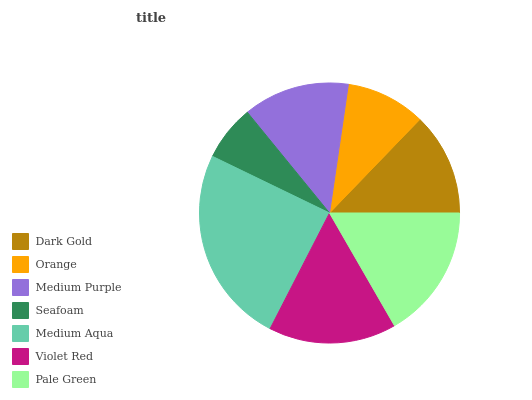Is Seafoam the minimum?
Answer yes or no. Yes. Is Medium Aqua the maximum?
Answer yes or no. Yes. Is Orange the minimum?
Answer yes or no. No. Is Orange the maximum?
Answer yes or no. No. Is Dark Gold greater than Orange?
Answer yes or no. Yes. Is Orange less than Dark Gold?
Answer yes or no. Yes. Is Orange greater than Dark Gold?
Answer yes or no. No. Is Dark Gold less than Orange?
Answer yes or no. No. Is Medium Purple the high median?
Answer yes or no. Yes. Is Medium Purple the low median?
Answer yes or no. Yes. Is Dark Gold the high median?
Answer yes or no. No. Is Pale Green the low median?
Answer yes or no. No. 